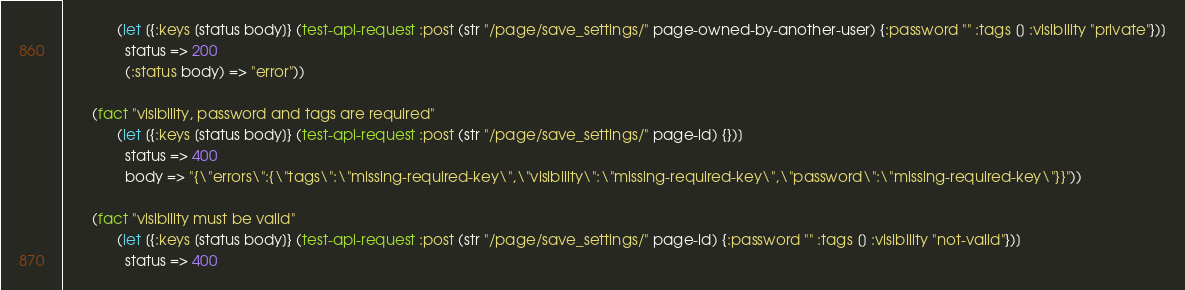<code> <loc_0><loc_0><loc_500><loc_500><_Clojure_>             (let [{:keys [status body]} (test-api-request :post (str "/page/save_settings/" page-owned-by-another-user) {:password "" :tags [] :visibility "private"})]
               status => 200
               (:status body) => "error"))

       (fact "visibility, password and tags are required"
             (let [{:keys [status body]} (test-api-request :post (str "/page/save_settings/" page-id) {})]
               status => 400
               body => "{\"errors\":{\"tags\":\"missing-required-key\",\"visibility\":\"missing-required-key\",\"password\":\"missing-required-key\"}}"))

       (fact "visibility must be valid"
             (let [{:keys [status body]} (test-api-request :post (str "/page/save_settings/" page-id) {:password "" :tags [] :visibility "not-valid"})]
               status => 400</code> 